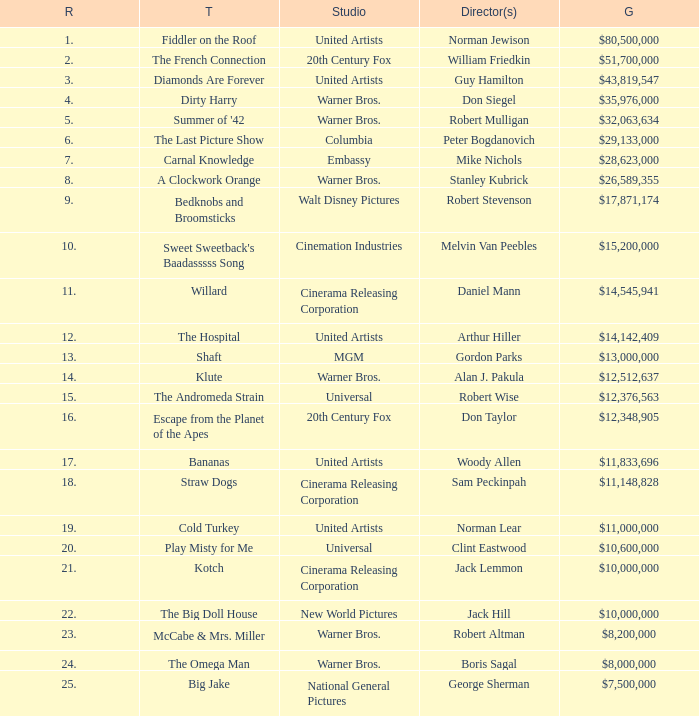Which title ranked lower than 19 has a gross of $11,833,696? Bananas. 